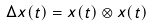<formula> <loc_0><loc_0><loc_500><loc_500>\Delta x ( t ) = x ( t ) \otimes x ( t )</formula> 